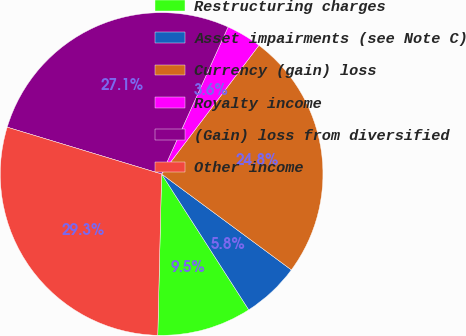Convert chart. <chart><loc_0><loc_0><loc_500><loc_500><pie_chart><fcel>Restructuring charges<fcel>Asset impairments (see Note C)<fcel>Currency (gain) loss<fcel>Royalty income<fcel>(Gain) loss from diversified<fcel>Other income<nl><fcel>9.46%<fcel>5.79%<fcel>24.82%<fcel>3.55%<fcel>27.07%<fcel>29.31%<nl></chart> 